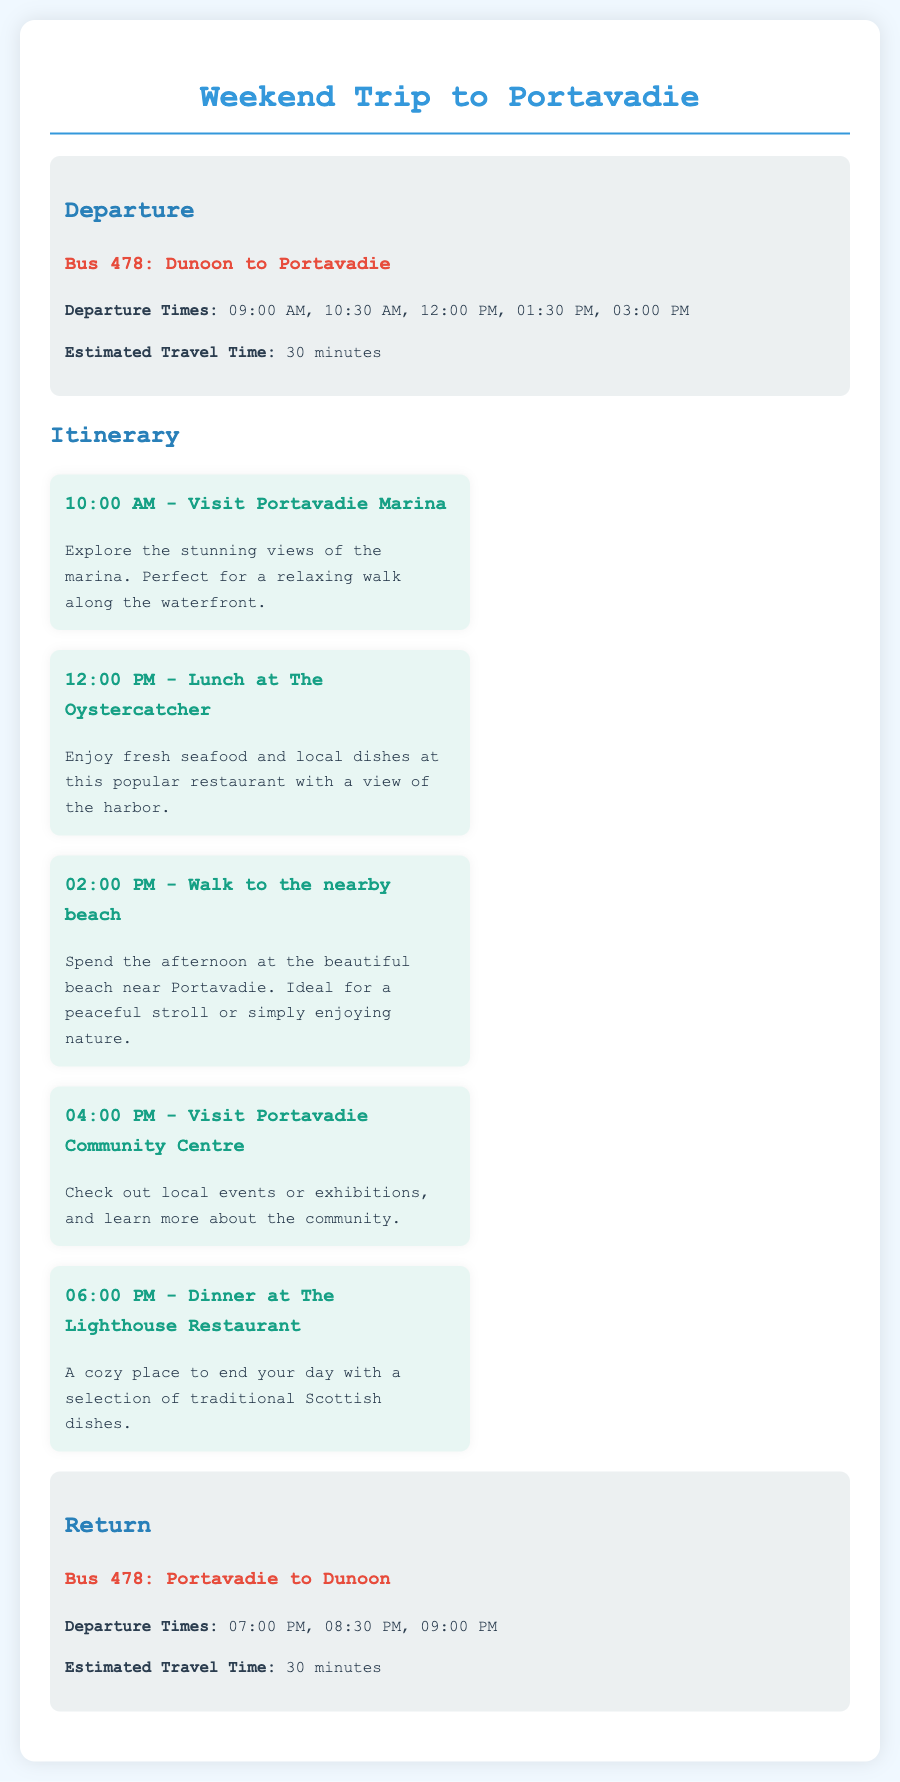What time does the first bus leave Dunoon? The first bus from Dunoon leaves at 09:00 AM according to the bus schedule.
Answer: 09:00 AM How long does it take to travel from Dunoon to Portavadie? The estimated travel time from Dunoon to Portavadie is stated to be 30 minutes.
Answer: 30 minutes What activity is scheduled at 02:00 PM? The itinerary mentions a walk to the nearby beach taking place at 02:00 PM.
Answer: Walk to the nearby beach Where can I have lunch in Portavadie? The document mentions "The Oystercatcher" as the place to have lunch at 12:00 PM.
Answer: The Oystercatcher What is the last bus departure time from Portavadie? According to the return schedule, the last bus leaves Portavadie at 09:00 PM.
Answer: 09:00 PM What type of cuisine does The Lighthouse Restaurant offer? The document indicates that The Lighthouse Restaurant has traditional Scottish dishes.
Answer: Traditional Scottish dishes What can be explored at 10:00 AM? At 10:00 AM, the activity is to visit Portavadie Marina, where stunning views can be explored.
Answer: Portavadie Marina How many bus departure times are listed for each direction? The document lists five departure times for Dunoon and three for Portavadie.
Answer: Five and three What activity can be done at 04:00 PM? The activity scheduled for 04:00 PM is a visit to the Portavadie Community Centre.
Answer: Visit Portavadie Community Centre 